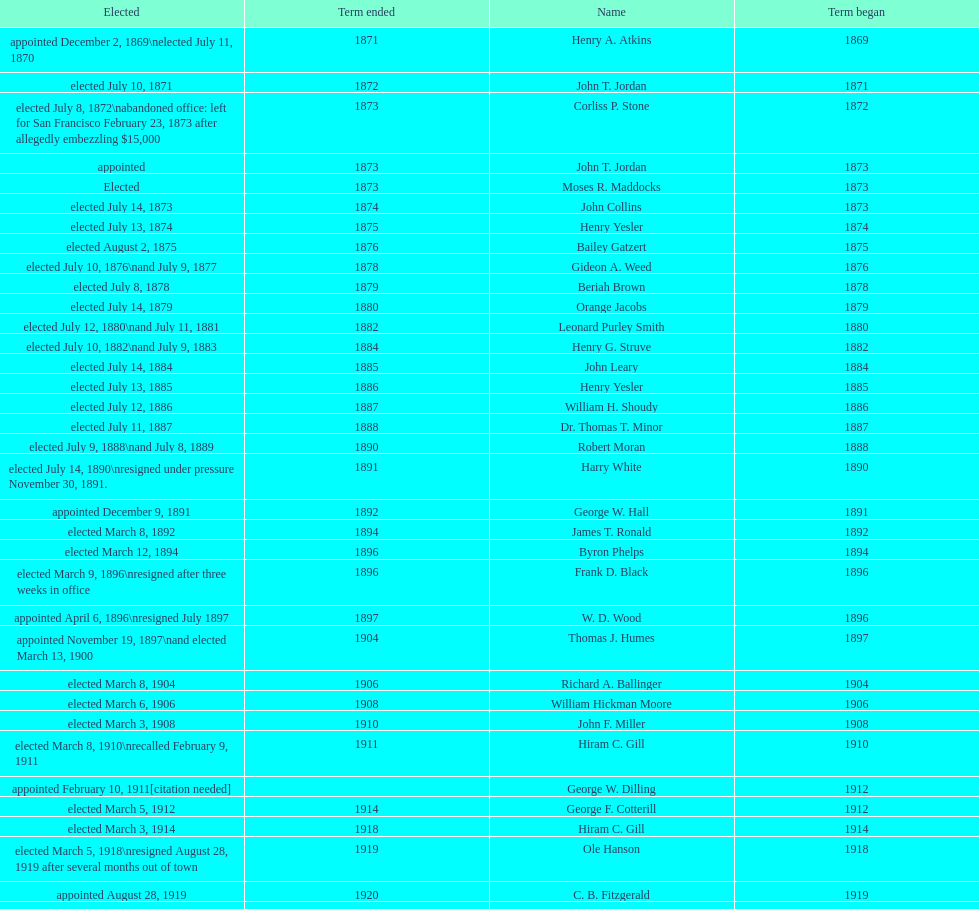Did charles royer hold office longer than paul schell? Yes. 